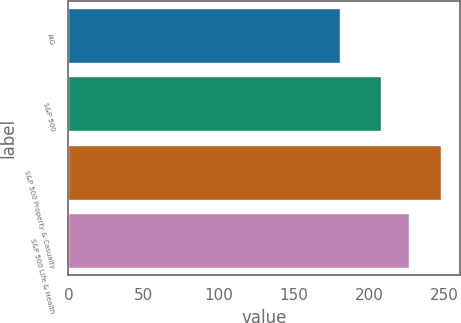<chart> <loc_0><loc_0><loc_500><loc_500><bar_chart><fcel>AIG<fcel>S&P 500<fcel>S&P 500 Property & Casualty<fcel>S&P 500 Life & Health<nl><fcel>181.03<fcel>208.14<fcel>248.26<fcel>226.98<nl></chart> 